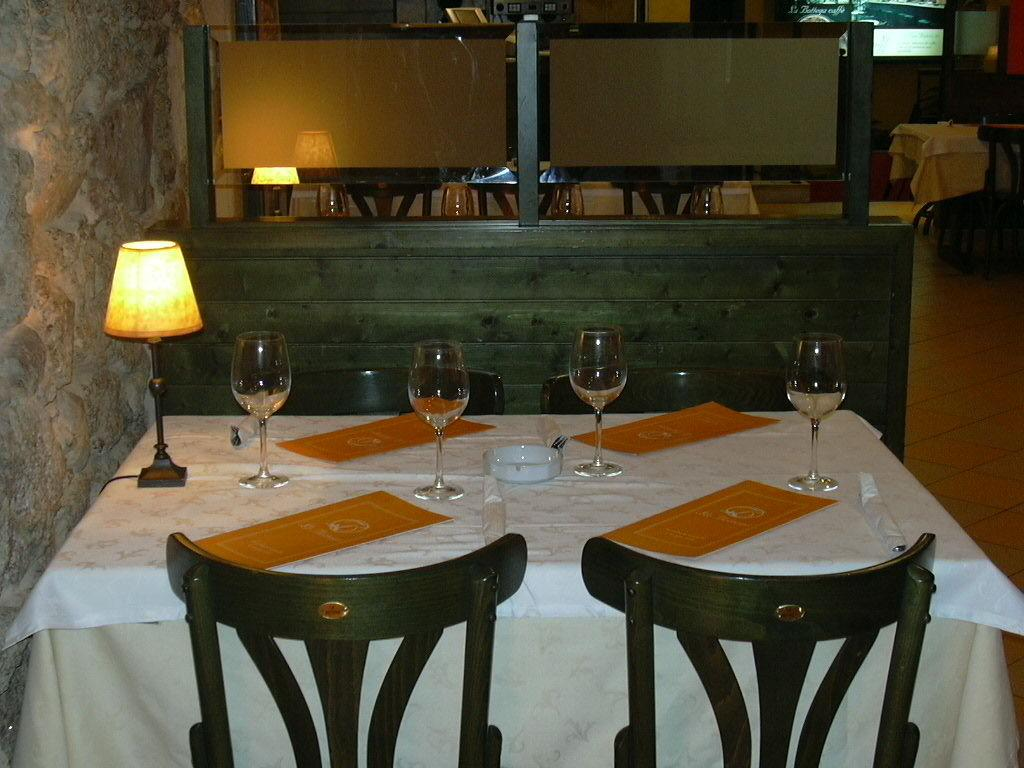What piece of furniture is present in the image? There is a table in the image. What objects are placed on the table? There are glasses, a lamp, a bowl, and menu cards on the table. Are there any seating options near the table? Yes, there are chairs near the table. What can be seen in the background of the image? In the background, there are tables and chairs on the floor. What is the purpose of the menu cards on the table? The menu cards on the table might be used for selecting food or drinks. What type of joke is being told by the tent in the image? There is no tent present in the image, so it is not possible to answer that question. 